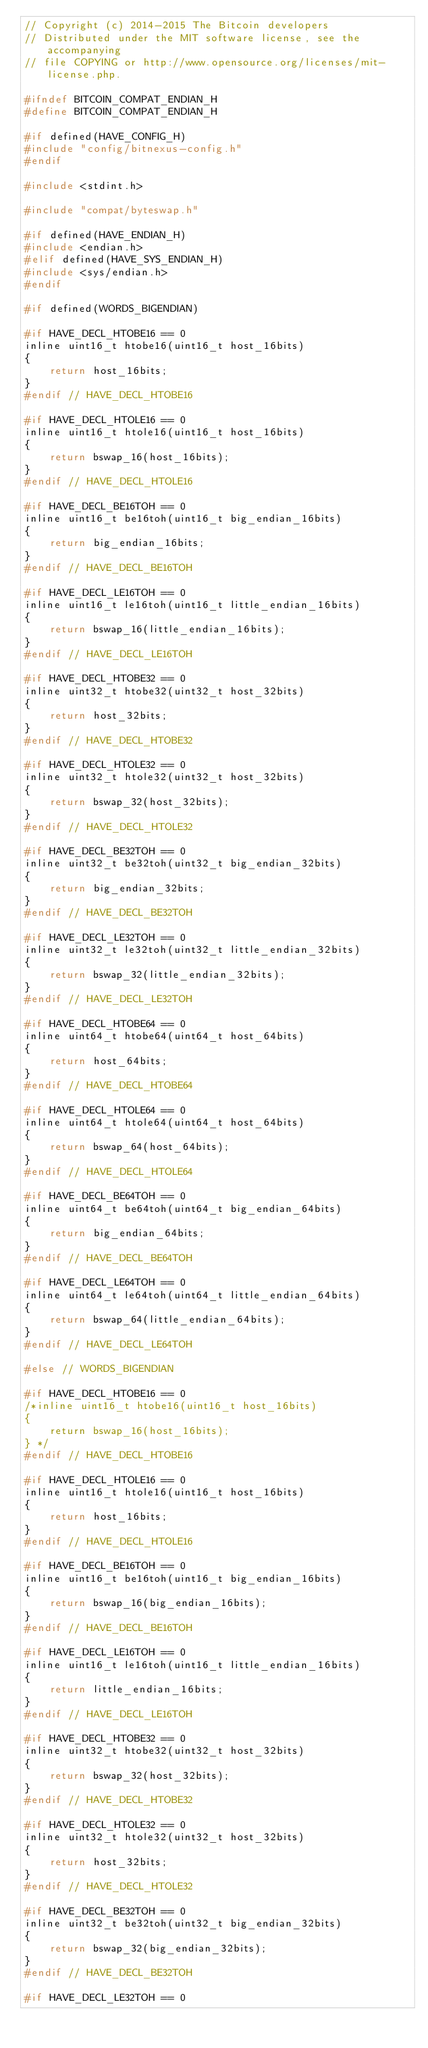Convert code to text. <code><loc_0><loc_0><loc_500><loc_500><_C_>// Copyright (c) 2014-2015 The Bitcoin developers
// Distributed under the MIT software license, see the accompanying
// file COPYING or http://www.opensource.org/licenses/mit-license.php.

#ifndef BITCOIN_COMPAT_ENDIAN_H
#define BITCOIN_COMPAT_ENDIAN_H

#if defined(HAVE_CONFIG_H)
#include "config/bitnexus-config.h"
#endif

#include <stdint.h>

#include "compat/byteswap.h"

#if defined(HAVE_ENDIAN_H)
#include <endian.h>
#elif defined(HAVE_SYS_ENDIAN_H)
#include <sys/endian.h>
#endif

#if defined(WORDS_BIGENDIAN)

#if HAVE_DECL_HTOBE16 == 0
inline uint16_t htobe16(uint16_t host_16bits)
{
    return host_16bits;
}
#endif // HAVE_DECL_HTOBE16

#if HAVE_DECL_HTOLE16 == 0
inline uint16_t htole16(uint16_t host_16bits)
{
    return bswap_16(host_16bits);
}
#endif // HAVE_DECL_HTOLE16

#if HAVE_DECL_BE16TOH == 0
inline uint16_t be16toh(uint16_t big_endian_16bits)
{
    return big_endian_16bits;
}
#endif // HAVE_DECL_BE16TOH

#if HAVE_DECL_LE16TOH == 0
inline uint16_t le16toh(uint16_t little_endian_16bits)
{
    return bswap_16(little_endian_16bits);
}
#endif // HAVE_DECL_LE16TOH

#if HAVE_DECL_HTOBE32 == 0
inline uint32_t htobe32(uint32_t host_32bits)
{
    return host_32bits;
}
#endif // HAVE_DECL_HTOBE32

#if HAVE_DECL_HTOLE32 == 0
inline uint32_t htole32(uint32_t host_32bits)
{
    return bswap_32(host_32bits);
}
#endif // HAVE_DECL_HTOLE32

#if HAVE_DECL_BE32TOH == 0
inline uint32_t be32toh(uint32_t big_endian_32bits)
{
    return big_endian_32bits;
}
#endif // HAVE_DECL_BE32TOH

#if HAVE_DECL_LE32TOH == 0
inline uint32_t le32toh(uint32_t little_endian_32bits)
{
    return bswap_32(little_endian_32bits);
}
#endif // HAVE_DECL_LE32TOH

#if HAVE_DECL_HTOBE64 == 0
inline uint64_t htobe64(uint64_t host_64bits)
{
    return host_64bits;
}
#endif // HAVE_DECL_HTOBE64

#if HAVE_DECL_HTOLE64 == 0
inline uint64_t htole64(uint64_t host_64bits)
{
    return bswap_64(host_64bits);
}
#endif // HAVE_DECL_HTOLE64

#if HAVE_DECL_BE64TOH == 0
inline uint64_t be64toh(uint64_t big_endian_64bits)
{
    return big_endian_64bits;
}
#endif // HAVE_DECL_BE64TOH

#if HAVE_DECL_LE64TOH == 0
inline uint64_t le64toh(uint64_t little_endian_64bits)
{
    return bswap_64(little_endian_64bits);
}
#endif // HAVE_DECL_LE64TOH

#else // WORDS_BIGENDIAN

#if HAVE_DECL_HTOBE16 == 0
/*inline uint16_t htobe16(uint16_t host_16bits)
{
    return bswap_16(host_16bits);
} */
#endif // HAVE_DECL_HTOBE16

#if HAVE_DECL_HTOLE16 == 0
inline uint16_t htole16(uint16_t host_16bits)
{
    return host_16bits;
}
#endif // HAVE_DECL_HTOLE16

#if HAVE_DECL_BE16TOH == 0
inline uint16_t be16toh(uint16_t big_endian_16bits)
{
    return bswap_16(big_endian_16bits);
}
#endif // HAVE_DECL_BE16TOH

#if HAVE_DECL_LE16TOH == 0
inline uint16_t le16toh(uint16_t little_endian_16bits)
{
    return little_endian_16bits;
}
#endif // HAVE_DECL_LE16TOH

#if HAVE_DECL_HTOBE32 == 0
inline uint32_t htobe32(uint32_t host_32bits)
{
    return bswap_32(host_32bits);
}
#endif // HAVE_DECL_HTOBE32

#if HAVE_DECL_HTOLE32 == 0
inline uint32_t htole32(uint32_t host_32bits)
{
    return host_32bits;
}
#endif // HAVE_DECL_HTOLE32

#if HAVE_DECL_BE32TOH == 0
inline uint32_t be32toh(uint32_t big_endian_32bits)
{
    return bswap_32(big_endian_32bits);
}
#endif // HAVE_DECL_BE32TOH

#if HAVE_DECL_LE32TOH == 0</code> 